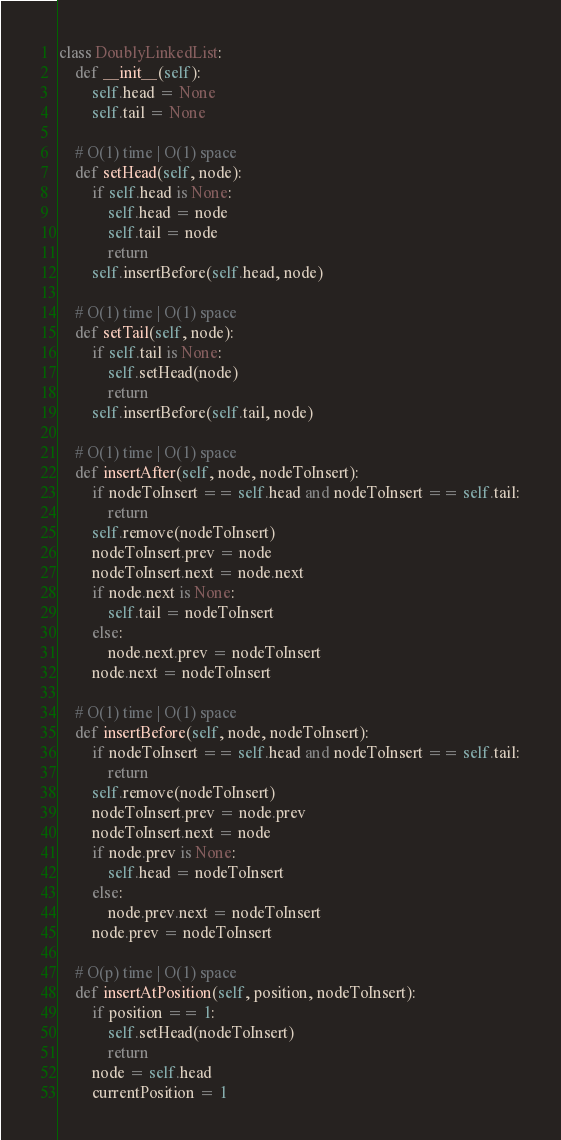Convert code to text. <code><loc_0><loc_0><loc_500><loc_500><_Python_>class DoublyLinkedList:
    def __init__(self):
        self.head = None
        self.tail = None

    # O(1) time | O(1) space
    def setHead(self, node):
        if self.head is None:
            self.head = node
            self.tail = node
            return
        self.insertBefore(self.head, node)

    # O(1) time | O(1) space
    def setTail(self, node):
        if self.tail is None:
            self.setHead(node)
            return
        self.insertBefore(self.tail, node)

    # O(1) time | O(1) space
    def insertAfter(self, node, nodeToInsert):
        if nodeToInsert == self.head and nodeToInsert == self.tail:
            return
        self.remove(nodeToInsert)
        nodeToInsert.prev = node
        nodeToInsert.next = node.next
        if node.next is None:
            self.tail = nodeToInsert
        else:
            node.next.prev = nodeToInsert
        node.next = nodeToInsert

    # O(1) time | O(1) space
    def insertBefore(self, node, nodeToInsert):
        if nodeToInsert == self.head and nodeToInsert == self.tail:
            return
        self.remove(nodeToInsert)
        nodeToInsert.prev = node.prev
        nodeToInsert.next = node
        if node.prev is None:
            self.head = nodeToInsert
        else:
            node.prev.next = nodeToInsert
        node.prev = nodeToInsert

    # O(p) time | O(1) space
    def insertAtPosition(self, position, nodeToInsert):
        if position == 1:
            self.setHead(nodeToInsert)
            return
        node = self.head
        currentPosition = 1</code> 